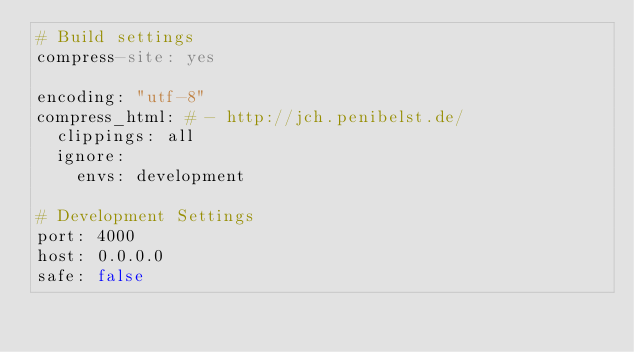Convert code to text. <code><loc_0><loc_0><loc_500><loc_500><_YAML_># Build settings
compress-site: yes

encoding: "utf-8"
compress_html: # - http://jch.penibelst.de/
  clippings: all
  ignore:
    envs: development

# Development Settings
port: 4000
host: 0.0.0.0
safe: false
</code> 